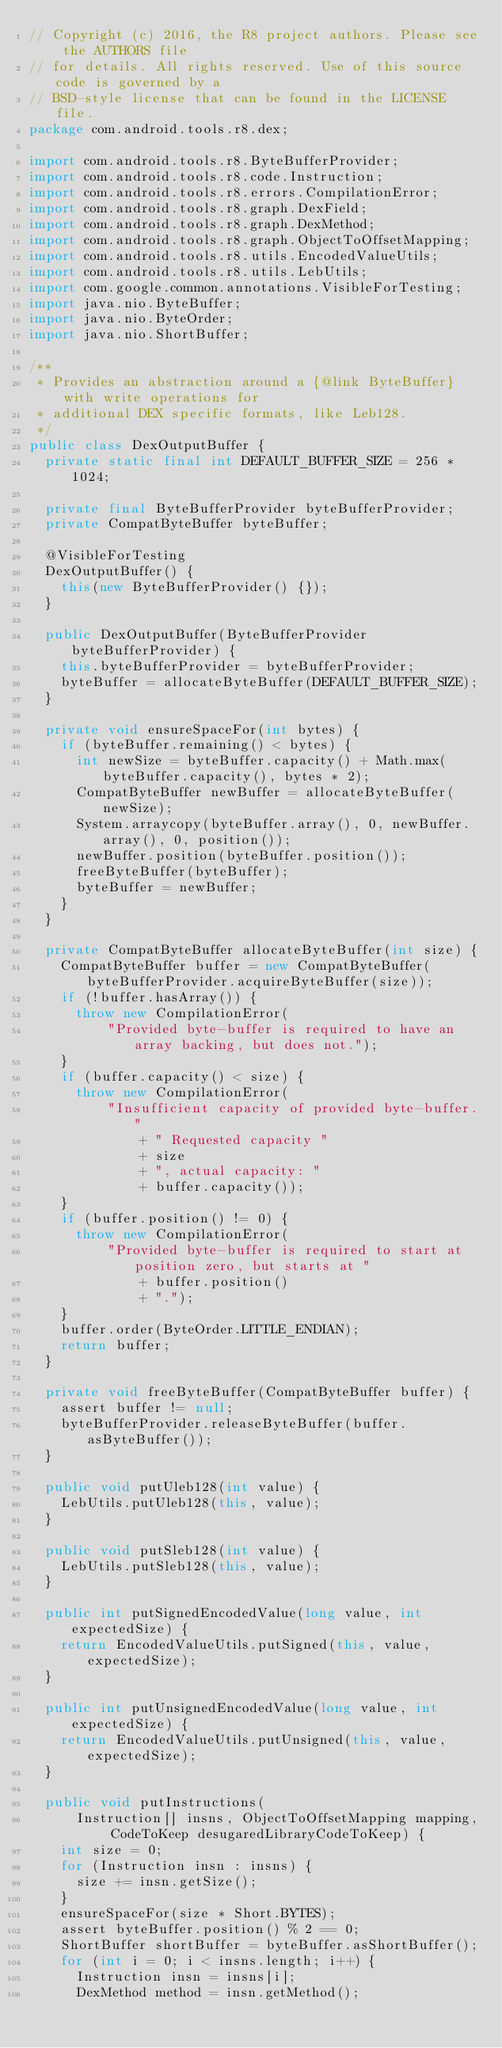Convert code to text. <code><loc_0><loc_0><loc_500><loc_500><_Java_>// Copyright (c) 2016, the R8 project authors. Please see the AUTHORS file
// for details. All rights reserved. Use of this source code is governed by a
// BSD-style license that can be found in the LICENSE file.
package com.android.tools.r8.dex;

import com.android.tools.r8.ByteBufferProvider;
import com.android.tools.r8.code.Instruction;
import com.android.tools.r8.errors.CompilationError;
import com.android.tools.r8.graph.DexField;
import com.android.tools.r8.graph.DexMethod;
import com.android.tools.r8.graph.ObjectToOffsetMapping;
import com.android.tools.r8.utils.EncodedValueUtils;
import com.android.tools.r8.utils.LebUtils;
import com.google.common.annotations.VisibleForTesting;
import java.nio.ByteBuffer;
import java.nio.ByteOrder;
import java.nio.ShortBuffer;

/**
 * Provides an abstraction around a {@link ByteBuffer} with write operations for
 * additional DEX specific formats, like Leb128.
 */
public class DexOutputBuffer {
  private static final int DEFAULT_BUFFER_SIZE = 256 * 1024;

  private final ByteBufferProvider byteBufferProvider;
  private CompatByteBuffer byteBuffer;

  @VisibleForTesting
  DexOutputBuffer() {
    this(new ByteBufferProvider() {});
  }

  public DexOutputBuffer(ByteBufferProvider byteBufferProvider) {
    this.byteBufferProvider = byteBufferProvider;
    byteBuffer = allocateByteBuffer(DEFAULT_BUFFER_SIZE);
  }

  private void ensureSpaceFor(int bytes) {
    if (byteBuffer.remaining() < bytes) {
      int newSize = byteBuffer.capacity() + Math.max(byteBuffer.capacity(), bytes * 2);
      CompatByteBuffer newBuffer = allocateByteBuffer(newSize);
      System.arraycopy(byteBuffer.array(), 0, newBuffer.array(), 0, position());
      newBuffer.position(byteBuffer.position());
      freeByteBuffer(byteBuffer);
      byteBuffer = newBuffer;
    }
  }

  private CompatByteBuffer allocateByteBuffer(int size) {
    CompatByteBuffer buffer = new CompatByteBuffer(byteBufferProvider.acquireByteBuffer(size));
    if (!buffer.hasArray()) {
      throw new CompilationError(
          "Provided byte-buffer is required to have an array backing, but does not.");
    }
    if (buffer.capacity() < size) {
      throw new CompilationError(
          "Insufficient capacity of provided byte-buffer."
              + " Requested capacity "
              + size
              + ", actual capacity: "
              + buffer.capacity());
    }
    if (buffer.position() != 0) {
      throw new CompilationError(
          "Provided byte-buffer is required to start at position zero, but starts at "
              + buffer.position()
              + ".");
    }
    buffer.order(ByteOrder.LITTLE_ENDIAN);
    return buffer;
  }

  private void freeByteBuffer(CompatByteBuffer buffer) {
    assert buffer != null;
    byteBufferProvider.releaseByteBuffer(buffer.asByteBuffer());
  }

  public void putUleb128(int value) {
    LebUtils.putUleb128(this, value);
  }

  public void putSleb128(int value) {
    LebUtils.putSleb128(this, value);
  }

  public int putSignedEncodedValue(long value, int expectedSize) {
    return EncodedValueUtils.putSigned(this, value, expectedSize);
  }

  public int putUnsignedEncodedValue(long value, int expectedSize) {
    return EncodedValueUtils.putUnsigned(this, value, expectedSize);
  }

  public void putInstructions(
      Instruction[] insns, ObjectToOffsetMapping mapping, CodeToKeep desugaredLibraryCodeToKeep) {
    int size = 0;
    for (Instruction insn : insns) {
      size += insn.getSize();
    }
    ensureSpaceFor(size * Short.BYTES);
    assert byteBuffer.position() % 2 == 0;
    ShortBuffer shortBuffer = byteBuffer.asShortBuffer();
    for (int i = 0; i < insns.length; i++) {
      Instruction insn = insns[i];
      DexMethod method = insn.getMethod();</code> 